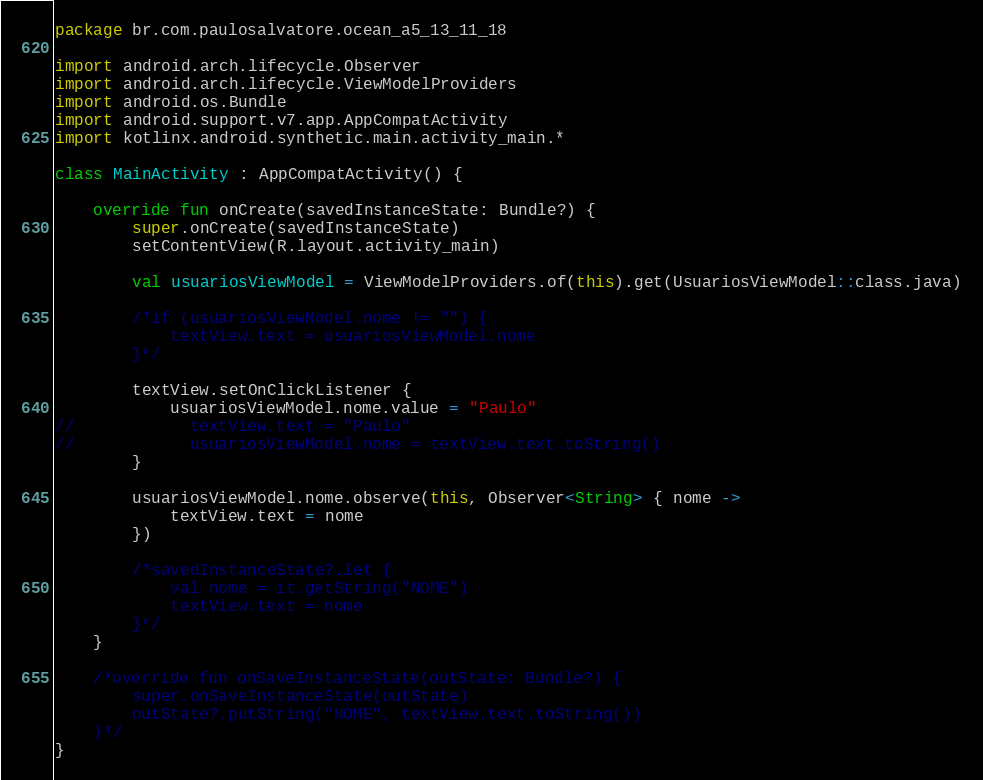Convert code to text. <code><loc_0><loc_0><loc_500><loc_500><_Kotlin_>package br.com.paulosalvatore.ocean_a5_13_11_18

import android.arch.lifecycle.Observer
import android.arch.lifecycle.ViewModelProviders
import android.os.Bundle
import android.support.v7.app.AppCompatActivity
import kotlinx.android.synthetic.main.activity_main.*

class MainActivity : AppCompatActivity() {

    override fun onCreate(savedInstanceState: Bundle?) {
        super.onCreate(savedInstanceState)
        setContentView(R.layout.activity_main)

	    val usuariosViewModel = ViewModelProviders.of(this).get(UsuariosViewModel::class.java)

        /*if (usuariosViewModel.nome != "") {
            textView.text = usuariosViewModel.nome
        }*/

        textView.setOnClickListener {
            usuariosViewModel.nome.value = "Paulo"
//            textView.text = "Paulo"
//            usuariosViewModel.nome = textView.text.toString()
        }

        usuariosViewModel.nome.observe(this, Observer<String> { nome ->
            textView.text = nome
        })

	    /*savedInstanceState?.let {
		    val nome = it.getString("NOME")
		    textView.text = nome
	    }*/
    }

	/*override fun onSaveInstanceState(outState: Bundle?) {
		super.onSaveInstanceState(outState)
		outState?.putString("NOME", textView.text.toString())
	}*/
}
</code> 